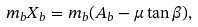<formula> <loc_0><loc_0><loc_500><loc_500>m _ { b } X _ { b } = m _ { b } ( A _ { b } - \mu \tan \beta ) ,</formula> 